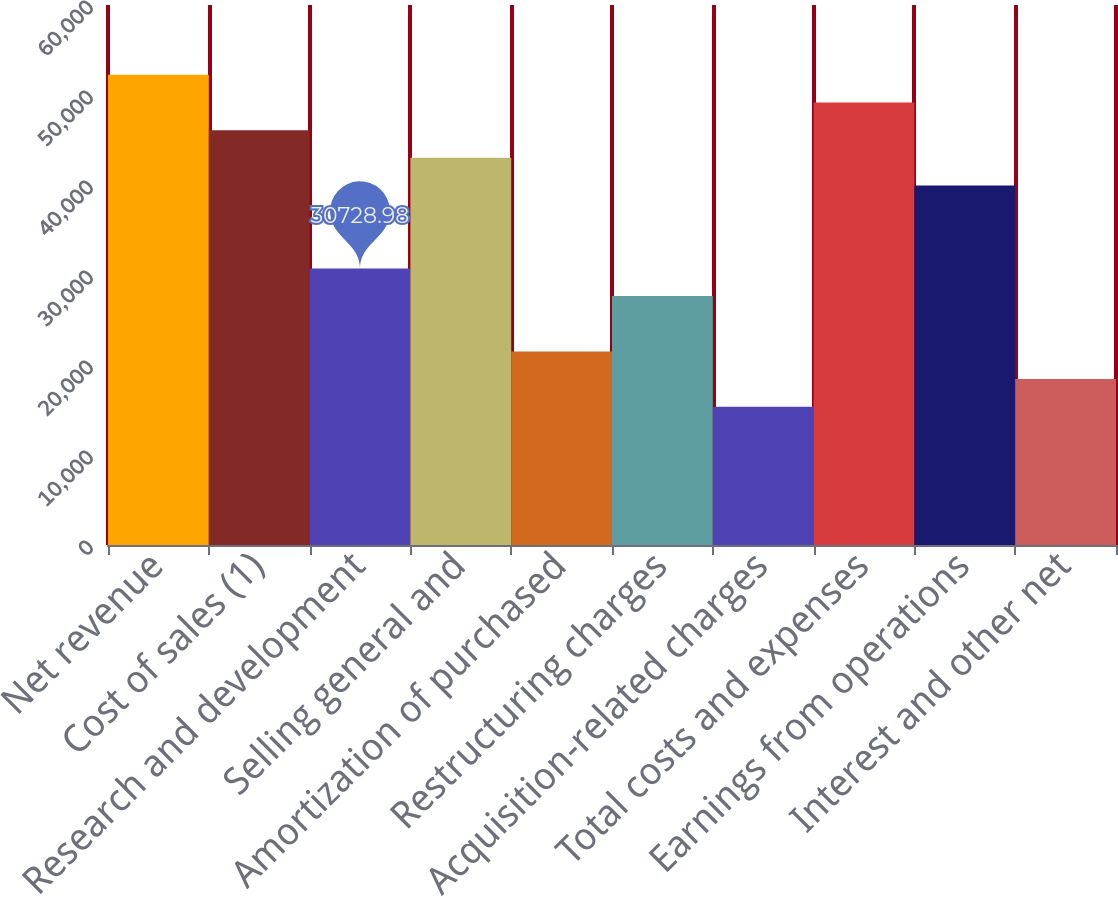<chart> <loc_0><loc_0><loc_500><loc_500><bar_chart><fcel>Net revenue<fcel>Cost of sales (1)<fcel>Research and development<fcel>Selling general and<fcel>Amortization of purchased<fcel>Restructuring charges<fcel>Acquisition-related charges<fcel>Total costs and expenses<fcel>Earnings from operations<fcel>Interest and other net<nl><fcel>52239.2<fcel>46093.4<fcel>30729<fcel>43020.5<fcel>21510.3<fcel>27656.1<fcel>15364.5<fcel>49166.3<fcel>39947.7<fcel>18437.4<nl></chart> 